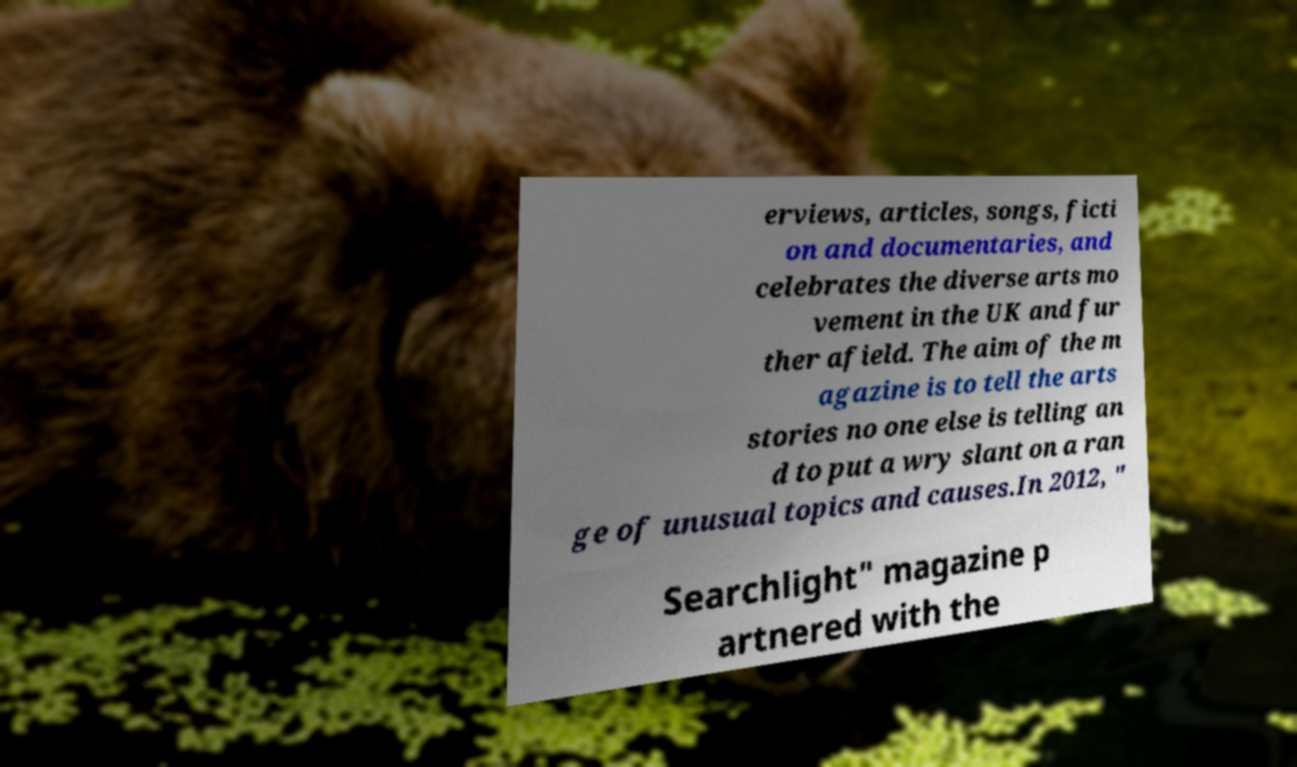Can you accurately transcribe the text from the provided image for me? erviews, articles, songs, ficti on and documentaries, and celebrates the diverse arts mo vement in the UK and fur ther afield. The aim of the m agazine is to tell the arts stories no one else is telling an d to put a wry slant on a ran ge of unusual topics and causes.In 2012, " Searchlight" magazine p artnered with the 